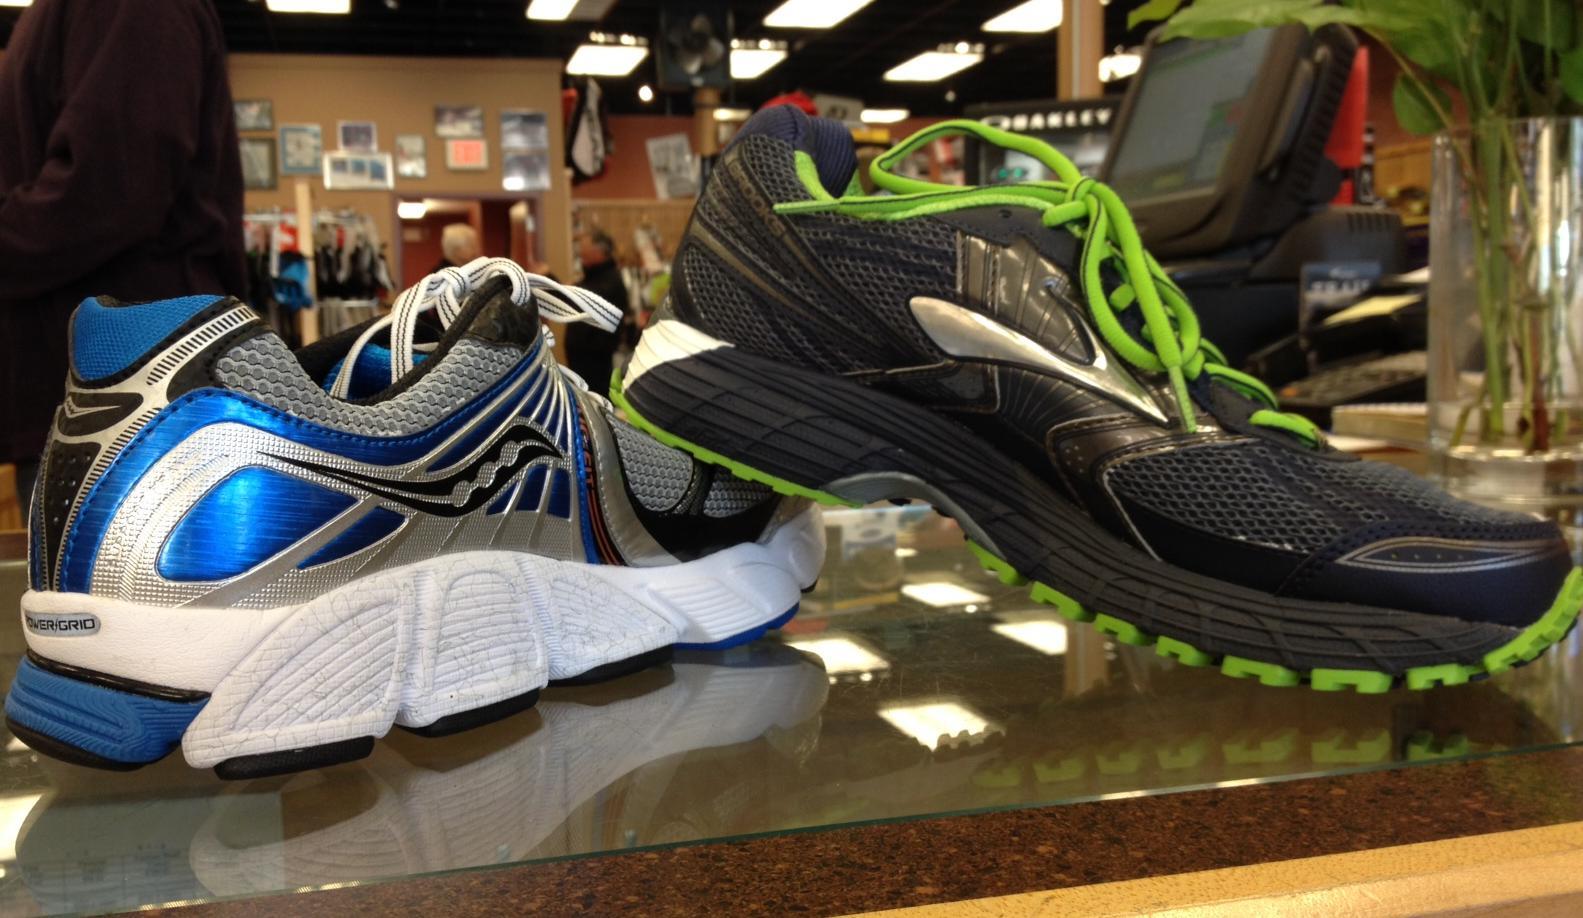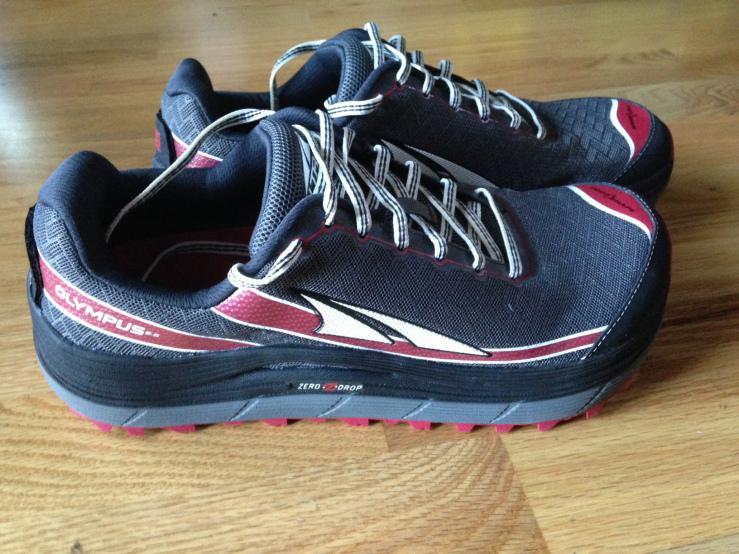The first image is the image on the left, the second image is the image on the right. Given the left and right images, does the statement "The shoes in the left image are facing opposite each other." hold true? Answer yes or no. No. The first image is the image on the left, the second image is the image on the right. Evaluate the accuracy of this statement regarding the images: "shoes are placed heel to heel". Is it true? Answer yes or no. No. 